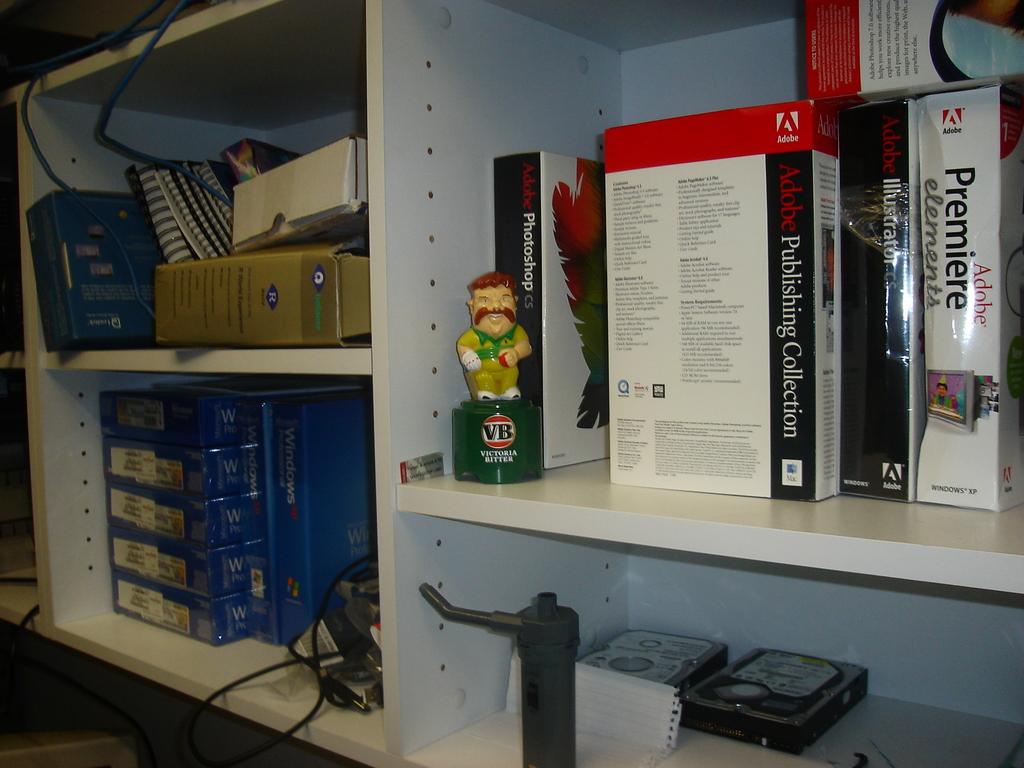What is the name mentioned on the base of the doll on the shelf?
Make the answer very short. Victoria bitter. What is on the shelf?
Your answer should be very brief. Adobe. 